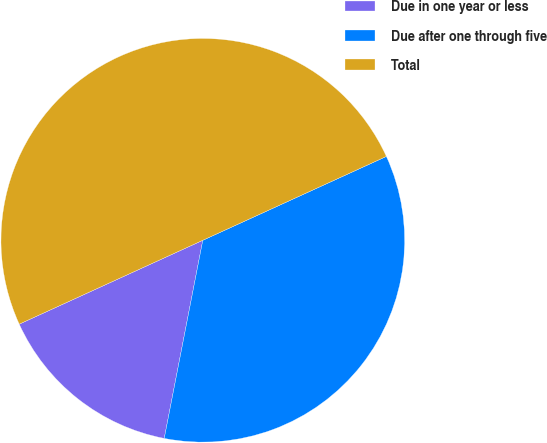<chart> <loc_0><loc_0><loc_500><loc_500><pie_chart><fcel>Due in one year or less<fcel>Due after one through five<fcel>Total<nl><fcel>15.12%<fcel>34.88%<fcel>50.0%<nl></chart> 